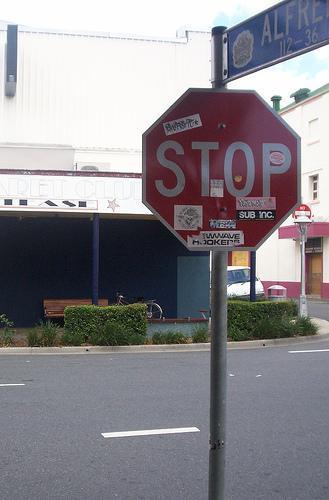How many of the street signs are blue?
Give a very brief answer. 1. 